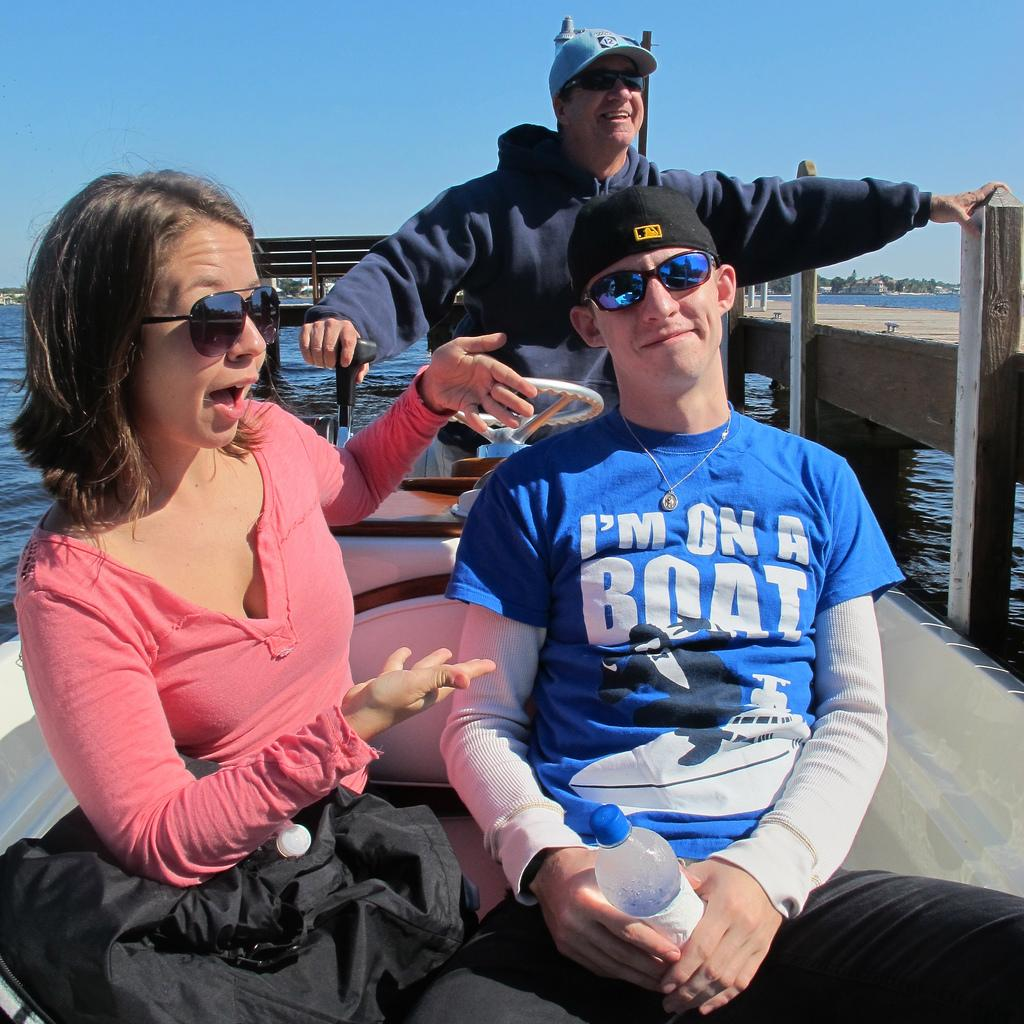<image>
Render a clear and concise summary of the photo. A guy wears a blue shirt with the phrase I'm on a boat. 